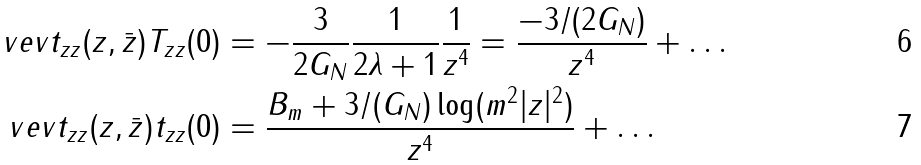Convert formula to latex. <formula><loc_0><loc_0><loc_500><loc_500>\ v e v { t _ { z z } ( z , \bar { z } ) T _ { z z } ( 0 ) } & = - \frac { 3 } { 2 G _ { N } } \frac { 1 } { 2 \lambda + 1 } \frac { 1 } { z ^ { 4 } } = \frac { - 3 / ( 2 G _ { N } ) } { z ^ { 4 } } + \dots \\ \ v e v { t _ { z z } ( z , \bar { z } ) t _ { z z } ( 0 ) } & = \frac { B _ { m } + 3 / ( G _ { N } ) \log ( m ^ { 2 } | z | ^ { 2 } ) } { z ^ { 4 } } + \dots</formula> 